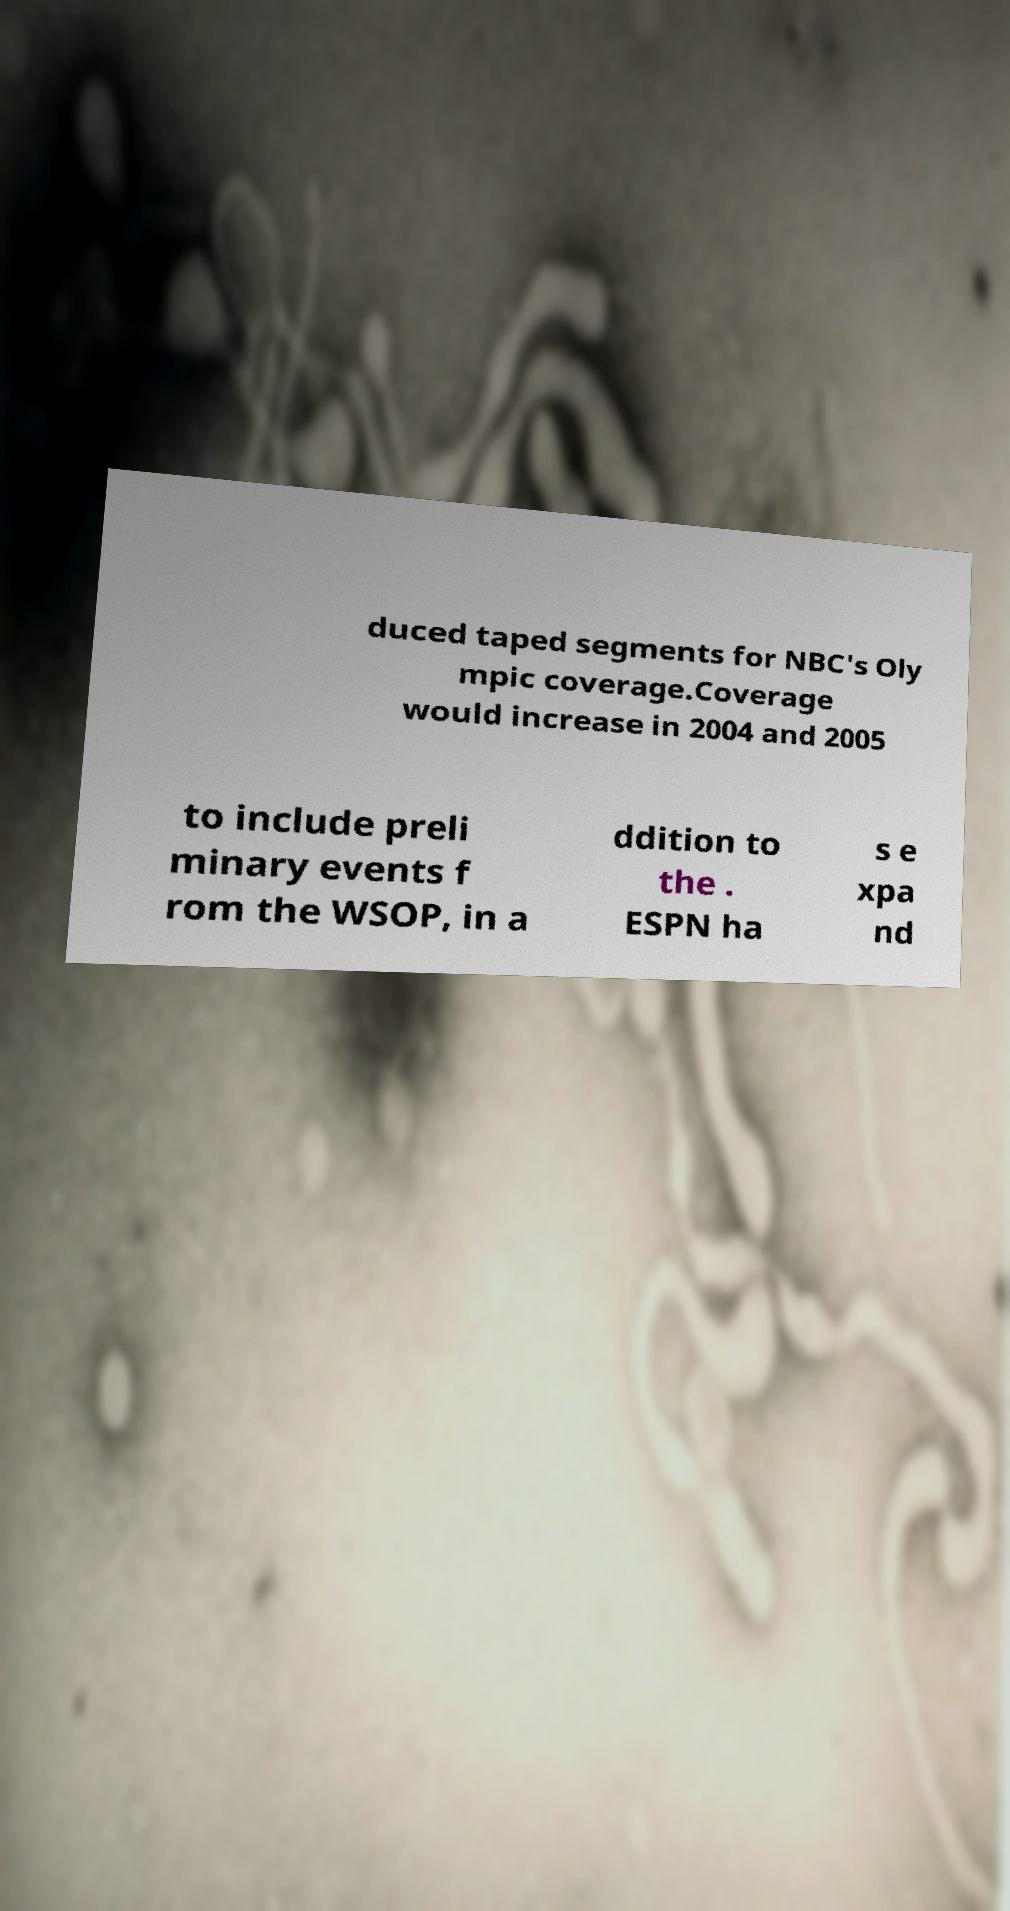For documentation purposes, I need the text within this image transcribed. Could you provide that? duced taped segments for NBC's Oly mpic coverage.Coverage would increase in 2004 and 2005 to include preli minary events f rom the WSOP, in a ddition to the . ESPN ha s e xpa nd 